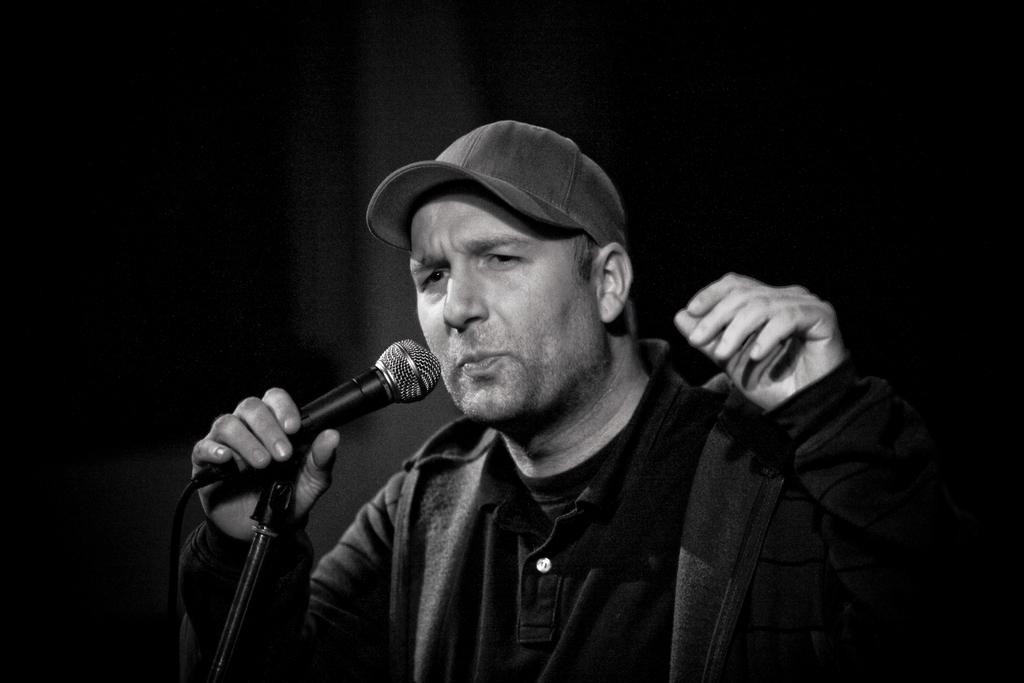What is the main subject of the picture? The main subject of the picture is a man. Can you describe what the man is wearing? The man is wearing a cap, a T-shirt, and a hoodie over the T-shirt. What is in front of the man? There is a microphone and a microphone stand in front of the man. What is the man doing with the microphone? The man is holding the microphone. What type of food is being served as a punishment in the image? There is no food or punishment present in the image; it features a man holding a microphone in front of a microphone stand. 